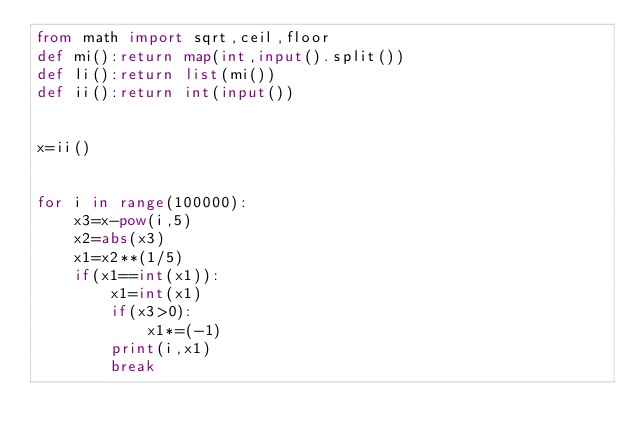<code> <loc_0><loc_0><loc_500><loc_500><_Python_>from math import sqrt,ceil,floor
def mi():return map(int,input().split())
def li():return list(mi())
def ii():return int(input())


x=ii()


for i in range(100000):
    x3=x-pow(i,5)
    x2=abs(x3)
    x1=x2**(1/5)
    if(x1==int(x1)):
        x1=int(x1)
        if(x3>0):
            x1*=(-1)
        print(i,x1)
        break
        </code> 